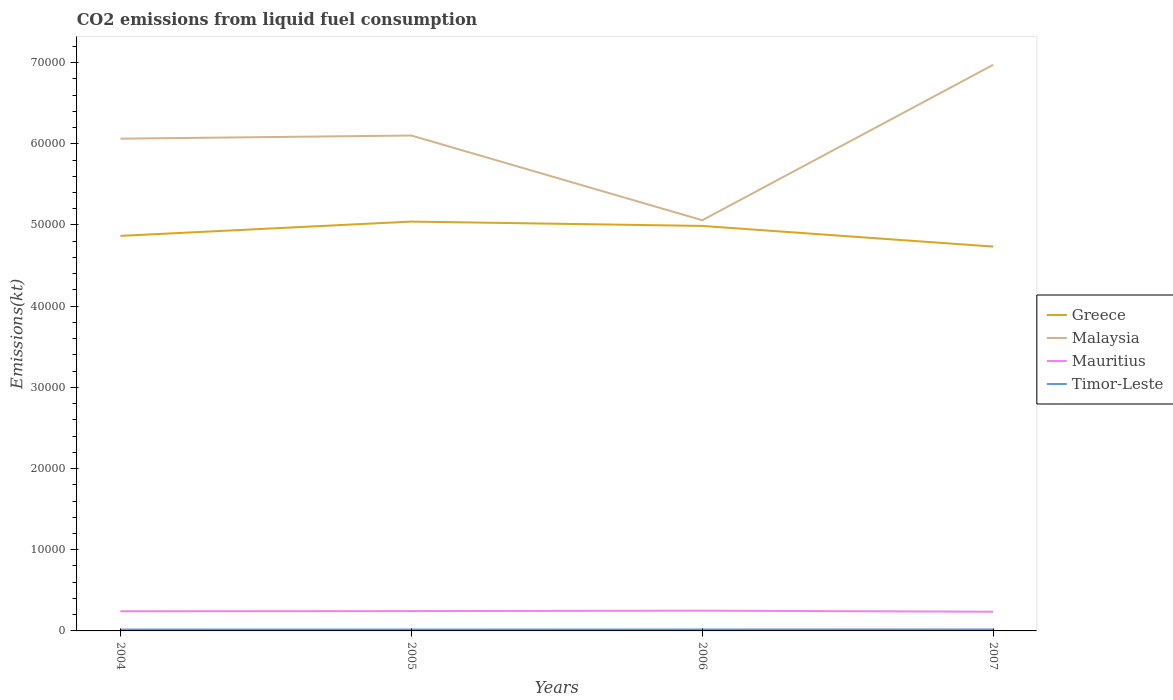How many different coloured lines are there?
Offer a terse response. 4. Does the line corresponding to Malaysia intersect with the line corresponding to Mauritius?
Provide a short and direct response. No. Is the number of lines equal to the number of legend labels?
Keep it short and to the point. Yes. Across all years, what is the maximum amount of CO2 emitted in Malaysia?
Your response must be concise. 5.06e+04. In which year was the amount of CO2 emitted in Mauritius maximum?
Offer a terse response. 2007. What is the total amount of CO2 emitted in Mauritius in the graph?
Make the answer very short. -18.34. What is the difference between the highest and the second highest amount of CO2 emitted in Mauritius?
Your answer should be compact. 128.34. Is the amount of CO2 emitted in Timor-Leste strictly greater than the amount of CO2 emitted in Greece over the years?
Make the answer very short. Yes. How many years are there in the graph?
Keep it short and to the point. 4. Does the graph contain any zero values?
Provide a succinct answer. No. How many legend labels are there?
Provide a succinct answer. 4. What is the title of the graph?
Offer a terse response. CO2 emissions from liquid fuel consumption. What is the label or title of the X-axis?
Make the answer very short. Years. What is the label or title of the Y-axis?
Ensure brevity in your answer.  Emissions(kt). What is the Emissions(kt) in Greece in 2004?
Keep it short and to the point. 4.87e+04. What is the Emissions(kt) in Malaysia in 2004?
Your answer should be compact. 6.06e+04. What is the Emissions(kt) of Mauritius in 2004?
Keep it short and to the point. 2423.89. What is the Emissions(kt) in Timor-Leste in 2004?
Make the answer very short. 176.02. What is the Emissions(kt) in Greece in 2005?
Your response must be concise. 5.04e+04. What is the Emissions(kt) of Malaysia in 2005?
Provide a succinct answer. 6.10e+04. What is the Emissions(kt) in Mauritius in 2005?
Your answer should be very brief. 2442.22. What is the Emissions(kt) in Timor-Leste in 2005?
Give a very brief answer. 176.02. What is the Emissions(kt) in Greece in 2006?
Offer a terse response. 4.99e+04. What is the Emissions(kt) of Malaysia in 2006?
Make the answer very short. 5.06e+04. What is the Emissions(kt) in Mauritius in 2006?
Make the answer very short. 2493.56. What is the Emissions(kt) of Timor-Leste in 2006?
Provide a succinct answer. 179.68. What is the Emissions(kt) of Greece in 2007?
Give a very brief answer. 4.73e+04. What is the Emissions(kt) in Malaysia in 2007?
Ensure brevity in your answer.  6.97e+04. What is the Emissions(kt) in Mauritius in 2007?
Your answer should be compact. 2365.22. What is the Emissions(kt) of Timor-Leste in 2007?
Give a very brief answer. 183.35. Across all years, what is the maximum Emissions(kt) in Greece?
Your response must be concise. 5.04e+04. Across all years, what is the maximum Emissions(kt) of Malaysia?
Ensure brevity in your answer.  6.97e+04. Across all years, what is the maximum Emissions(kt) of Mauritius?
Provide a succinct answer. 2493.56. Across all years, what is the maximum Emissions(kt) in Timor-Leste?
Offer a very short reply. 183.35. Across all years, what is the minimum Emissions(kt) in Greece?
Your answer should be compact. 4.73e+04. Across all years, what is the minimum Emissions(kt) of Malaysia?
Your answer should be very brief. 5.06e+04. Across all years, what is the minimum Emissions(kt) of Mauritius?
Give a very brief answer. 2365.22. Across all years, what is the minimum Emissions(kt) of Timor-Leste?
Give a very brief answer. 176.02. What is the total Emissions(kt) in Greece in the graph?
Provide a short and direct response. 1.96e+05. What is the total Emissions(kt) of Malaysia in the graph?
Provide a succinct answer. 2.42e+05. What is the total Emissions(kt) of Mauritius in the graph?
Your response must be concise. 9724.88. What is the total Emissions(kt) in Timor-Leste in the graph?
Offer a very short reply. 715.07. What is the difference between the Emissions(kt) in Greece in 2004 and that in 2005?
Offer a terse response. -1760.16. What is the difference between the Emissions(kt) of Malaysia in 2004 and that in 2005?
Make the answer very short. -388.7. What is the difference between the Emissions(kt) in Mauritius in 2004 and that in 2005?
Offer a terse response. -18.34. What is the difference between the Emissions(kt) of Timor-Leste in 2004 and that in 2005?
Your answer should be very brief. 0. What is the difference between the Emissions(kt) in Greece in 2004 and that in 2006?
Make the answer very short. -1224.78. What is the difference between the Emissions(kt) of Malaysia in 2004 and that in 2006?
Ensure brevity in your answer.  1.00e+04. What is the difference between the Emissions(kt) of Mauritius in 2004 and that in 2006?
Your answer should be very brief. -69.67. What is the difference between the Emissions(kt) of Timor-Leste in 2004 and that in 2006?
Your answer should be very brief. -3.67. What is the difference between the Emissions(kt) of Greece in 2004 and that in 2007?
Keep it short and to the point. 1320.12. What is the difference between the Emissions(kt) in Malaysia in 2004 and that in 2007?
Offer a very short reply. -9097.83. What is the difference between the Emissions(kt) of Mauritius in 2004 and that in 2007?
Give a very brief answer. 58.67. What is the difference between the Emissions(kt) of Timor-Leste in 2004 and that in 2007?
Provide a succinct answer. -7.33. What is the difference between the Emissions(kt) of Greece in 2005 and that in 2006?
Give a very brief answer. 535.38. What is the difference between the Emissions(kt) of Malaysia in 2005 and that in 2006?
Offer a terse response. 1.04e+04. What is the difference between the Emissions(kt) in Mauritius in 2005 and that in 2006?
Give a very brief answer. -51.34. What is the difference between the Emissions(kt) of Timor-Leste in 2005 and that in 2006?
Keep it short and to the point. -3.67. What is the difference between the Emissions(kt) in Greece in 2005 and that in 2007?
Make the answer very short. 3080.28. What is the difference between the Emissions(kt) in Malaysia in 2005 and that in 2007?
Your answer should be compact. -8709.12. What is the difference between the Emissions(kt) of Mauritius in 2005 and that in 2007?
Give a very brief answer. 77.01. What is the difference between the Emissions(kt) in Timor-Leste in 2005 and that in 2007?
Make the answer very short. -7.33. What is the difference between the Emissions(kt) of Greece in 2006 and that in 2007?
Your response must be concise. 2544.9. What is the difference between the Emissions(kt) in Malaysia in 2006 and that in 2007?
Make the answer very short. -1.91e+04. What is the difference between the Emissions(kt) of Mauritius in 2006 and that in 2007?
Your answer should be compact. 128.34. What is the difference between the Emissions(kt) of Timor-Leste in 2006 and that in 2007?
Keep it short and to the point. -3.67. What is the difference between the Emissions(kt) in Greece in 2004 and the Emissions(kt) in Malaysia in 2005?
Give a very brief answer. -1.24e+04. What is the difference between the Emissions(kt) of Greece in 2004 and the Emissions(kt) of Mauritius in 2005?
Offer a very short reply. 4.62e+04. What is the difference between the Emissions(kt) in Greece in 2004 and the Emissions(kt) in Timor-Leste in 2005?
Your answer should be compact. 4.85e+04. What is the difference between the Emissions(kt) of Malaysia in 2004 and the Emissions(kt) of Mauritius in 2005?
Offer a terse response. 5.82e+04. What is the difference between the Emissions(kt) of Malaysia in 2004 and the Emissions(kt) of Timor-Leste in 2005?
Your response must be concise. 6.05e+04. What is the difference between the Emissions(kt) of Mauritius in 2004 and the Emissions(kt) of Timor-Leste in 2005?
Give a very brief answer. 2247.87. What is the difference between the Emissions(kt) in Greece in 2004 and the Emissions(kt) in Malaysia in 2006?
Your answer should be compact. -1925.17. What is the difference between the Emissions(kt) in Greece in 2004 and the Emissions(kt) in Mauritius in 2006?
Offer a terse response. 4.62e+04. What is the difference between the Emissions(kt) of Greece in 2004 and the Emissions(kt) of Timor-Leste in 2006?
Your response must be concise. 4.85e+04. What is the difference between the Emissions(kt) in Malaysia in 2004 and the Emissions(kt) in Mauritius in 2006?
Your answer should be very brief. 5.81e+04. What is the difference between the Emissions(kt) in Malaysia in 2004 and the Emissions(kt) in Timor-Leste in 2006?
Ensure brevity in your answer.  6.05e+04. What is the difference between the Emissions(kt) in Mauritius in 2004 and the Emissions(kt) in Timor-Leste in 2006?
Offer a very short reply. 2244.2. What is the difference between the Emissions(kt) in Greece in 2004 and the Emissions(kt) in Malaysia in 2007?
Your answer should be compact. -2.11e+04. What is the difference between the Emissions(kt) in Greece in 2004 and the Emissions(kt) in Mauritius in 2007?
Ensure brevity in your answer.  4.63e+04. What is the difference between the Emissions(kt) in Greece in 2004 and the Emissions(kt) in Timor-Leste in 2007?
Make the answer very short. 4.85e+04. What is the difference between the Emissions(kt) of Malaysia in 2004 and the Emissions(kt) of Mauritius in 2007?
Make the answer very short. 5.83e+04. What is the difference between the Emissions(kt) of Malaysia in 2004 and the Emissions(kt) of Timor-Leste in 2007?
Make the answer very short. 6.05e+04. What is the difference between the Emissions(kt) in Mauritius in 2004 and the Emissions(kt) in Timor-Leste in 2007?
Keep it short and to the point. 2240.54. What is the difference between the Emissions(kt) of Greece in 2005 and the Emissions(kt) of Malaysia in 2006?
Offer a terse response. -165.01. What is the difference between the Emissions(kt) of Greece in 2005 and the Emissions(kt) of Mauritius in 2006?
Ensure brevity in your answer.  4.79e+04. What is the difference between the Emissions(kt) in Greece in 2005 and the Emissions(kt) in Timor-Leste in 2006?
Provide a short and direct response. 5.02e+04. What is the difference between the Emissions(kt) of Malaysia in 2005 and the Emissions(kt) of Mauritius in 2006?
Provide a succinct answer. 5.85e+04. What is the difference between the Emissions(kt) of Malaysia in 2005 and the Emissions(kt) of Timor-Leste in 2006?
Ensure brevity in your answer.  6.08e+04. What is the difference between the Emissions(kt) of Mauritius in 2005 and the Emissions(kt) of Timor-Leste in 2006?
Keep it short and to the point. 2262.54. What is the difference between the Emissions(kt) of Greece in 2005 and the Emissions(kt) of Malaysia in 2007?
Keep it short and to the point. -1.93e+04. What is the difference between the Emissions(kt) of Greece in 2005 and the Emissions(kt) of Mauritius in 2007?
Your answer should be very brief. 4.81e+04. What is the difference between the Emissions(kt) in Greece in 2005 and the Emissions(kt) in Timor-Leste in 2007?
Provide a succinct answer. 5.02e+04. What is the difference between the Emissions(kt) of Malaysia in 2005 and the Emissions(kt) of Mauritius in 2007?
Your answer should be very brief. 5.87e+04. What is the difference between the Emissions(kt) of Malaysia in 2005 and the Emissions(kt) of Timor-Leste in 2007?
Your answer should be compact. 6.08e+04. What is the difference between the Emissions(kt) of Mauritius in 2005 and the Emissions(kt) of Timor-Leste in 2007?
Offer a very short reply. 2258.87. What is the difference between the Emissions(kt) in Greece in 2006 and the Emissions(kt) in Malaysia in 2007?
Ensure brevity in your answer.  -1.98e+04. What is the difference between the Emissions(kt) in Greece in 2006 and the Emissions(kt) in Mauritius in 2007?
Provide a short and direct response. 4.75e+04. What is the difference between the Emissions(kt) of Greece in 2006 and the Emissions(kt) of Timor-Leste in 2007?
Your response must be concise. 4.97e+04. What is the difference between the Emissions(kt) in Malaysia in 2006 and the Emissions(kt) in Mauritius in 2007?
Offer a very short reply. 4.82e+04. What is the difference between the Emissions(kt) of Malaysia in 2006 and the Emissions(kt) of Timor-Leste in 2007?
Your response must be concise. 5.04e+04. What is the difference between the Emissions(kt) in Mauritius in 2006 and the Emissions(kt) in Timor-Leste in 2007?
Provide a succinct answer. 2310.21. What is the average Emissions(kt) of Greece per year?
Offer a very short reply. 4.91e+04. What is the average Emissions(kt) of Malaysia per year?
Keep it short and to the point. 6.05e+04. What is the average Emissions(kt) of Mauritius per year?
Provide a succinct answer. 2431.22. What is the average Emissions(kt) of Timor-Leste per year?
Make the answer very short. 178.77. In the year 2004, what is the difference between the Emissions(kt) of Greece and Emissions(kt) of Malaysia?
Keep it short and to the point. -1.20e+04. In the year 2004, what is the difference between the Emissions(kt) of Greece and Emissions(kt) of Mauritius?
Keep it short and to the point. 4.62e+04. In the year 2004, what is the difference between the Emissions(kt) in Greece and Emissions(kt) in Timor-Leste?
Your response must be concise. 4.85e+04. In the year 2004, what is the difference between the Emissions(kt) of Malaysia and Emissions(kt) of Mauritius?
Make the answer very short. 5.82e+04. In the year 2004, what is the difference between the Emissions(kt) in Malaysia and Emissions(kt) in Timor-Leste?
Give a very brief answer. 6.05e+04. In the year 2004, what is the difference between the Emissions(kt) in Mauritius and Emissions(kt) in Timor-Leste?
Your answer should be very brief. 2247.87. In the year 2005, what is the difference between the Emissions(kt) of Greece and Emissions(kt) of Malaysia?
Provide a succinct answer. -1.06e+04. In the year 2005, what is the difference between the Emissions(kt) of Greece and Emissions(kt) of Mauritius?
Provide a succinct answer. 4.80e+04. In the year 2005, what is the difference between the Emissions(kt) of Greece and Emissions(kt) of Timor-Leste?
Your answer should be very brief. 5.02e+04. In the year 2005, what is the difference between the Emissions(kt) in Malaysia and Emissions(kt) in Mauritius?
Keep it short and to the point. 5.86e+04. In the year 2005, what is the difference between the Emissions(kt) in Malaysia and Emissions(kt) in Timor-Leste?
Give a very brief answer. 6.08e+04. In the year 2005, what is the difference between the Emissions(kt) in Mauritius and Emissions(kt) in Timor-Leste?
Your answer should be compact. 2266.21. In the year 2006, what is the difference between the Emissions(kt) of Greece and Emissions(kt) of Malaysia?
Your answer should be compact. -700.4. In the year 2006, what is the difference between the Emissions(kt) in Greece and Emissions(kt) in Mauritius?
Ensure brevity in your answer.  4.74e+04. In the year 2006, what is the difference between the Emissions(kt) in Greece and Emissions(kt) in Timor-Leste?
Provide a succinct answer. 4.97e+04. In the year 2006, what is the difference between the Emissions(kt) in Malaysia and Emissions(kt) in Mauritius?
Give a very brief answer. 4.81e+04. In the year 2006, what is the difference between the Emissions(kt) of Malaysia and Emissions(kt) of Timor-Leste?
Make the answer very short. 5.04e+04. In the year 2006, what is the difference between the Emissions(kt) in Mauritius and Emissions(kt) in Timor-Leste?
Your answer should be very brief. 2313.88. In the year 2007, what is the difference between the Emissions(kt) of Greece and Emissions(kt) of Malaysia?
Your response must be concise. -2.24e+04. In the year 2007, what is the difference between the Emissions(kt) of Greece and Emissions(kt) of Mauritius?
Provide a short and direct response. 4.50e+04. In the year 2007, what is the difference between the Emissions(kt) in Greece and Emissions(kt) in Timor-Leste?
Your response must be concise. 4.72e+04. In the year 2007, what is the difference between the Emissions(kt) of Malaysia and Emissions(kt) of Mauritius?
Provide a succinct answer. 6.74e+04. In the year 2007, what is the difference between the Emissions(kt) in Malaysia and Emissions(kt) in Timor-Leste?
Your answer should be very brief. 6.95e+04. In the year 2007, what is the difference between the Emissions(kt) of Mauritius and Emissions(kt) of Timor-Leste?
Keep it short and to the point. 2181.86. What is the ratio of the Emissions(kt) of Greece in 2004 to that in 2005?
Your answer should be very brief. 0.97. What is the ratio of the Emissions(kt) of Malaysia in 2004 to that in 2005?
Offer a terse response. 0.99. What is the ratio of the Emissions(kt) in Mauritius in 2004 to that in 2005?
Your answer should be compact. 0.99. What is the ratio of the Emissions(kt) of Timor-Leste in 2004 to that in 2005?
Offer a very short reply. 1. What is the ratio of the Emissions(kt) of Greece in 2004 to that in 2006?
Your answer should be compact. 0.98. What is the ratio of the Emissions(kt) of Malaysia in 2004 to that in 2006?
Provide a succinct answer. 1.2. What is the ratio of the Emissions(kt) of Mauritius in 2004 to that in 2006?
Your answer should be compact. 0.97. What is the ratio of the Emissions(kt) in Timor-Leste in 2004 to that in 2006?
Your answer should be compact. 0.98. What is the ratio of the Emissions(kt) of Greece in 2004 to that in 2007?
Provide a short and direct response. 1.03. What is the ratio of the Emissions(kt) of Malaysia in 2004 to that in 2007?
Make the answer very short. 0.87. What is the ratio of the Emissions(kt) in Mauritius in 2004 to that in 2007?
Provide a short and direct response. 1.02. What is the ratio of the Emissions(kt) of Timor-Leste in 2004 to that in 2007?
Your response must be concise. 0.96. What is the ratio of the Emissions(kt) in Greece in 2005 to that in 2006?
Your answer should be compact. 1.01. What is the ratio of the Emissions(kt) of Malaysia in 2005 to that in 2006?
Provide a short and direct response. 1.21. What is the ratio of the Emissions(kt) in Mauritius in 2005 to that in 2006?
Your answer should be compact. 0.98. What is the ratio of the Emissions(kt) in Timor-Leste in 2005 to that in 2006?
Keep it short and to the point. 0.98. What is the ratio of the Emissions(kt) of Greece in 2005 to that in 2007?
Keep it short and to the point. 1.07. What is the ratio of the Emissions(kt) of Malaysia in 2005 to that in 2007?
Make the answer very short. 0.88. What is the ratio of the Emissions(kt) of Mauritius in 2005 to that in 2007?
Ensure brevity in your answer.  1.03. What is the ratio of the Emissions(kt) in Timor-Leste in 2005 to that in 2007?
Give a very brief answer. 0.96. What is the ratio of the Emissions(kt) in Greece in 2006 to that in 2007?
Offer a very short reply. 1.05. What is the ratio of the Emissions(kt) of Malaysia in 2006 to that in 2007?
Offer a very short reply. 0.73. What is the ratio of the Emissions(kt) of Mauritius in 2006 to that in 2007?
Your response must be concise. 1.05. What is the ratio of the Emissions(kt) in Timor-Leste in 2006 to that in 2007?
Your answer should be compact. 0.98. What is the difference between the highest and the second highest Emissions(kt) in Greece?
Offer a very short reply. 535.38. What is the difference between the highest and the second highest Emissions(kt) in Malaysia?
Provide a short and direct response. 8709.12. What is the difference between the highest and the second highest Emissions(kt) of Mauritius?
Your answer should be very brief. 51.34. What is the difference between the highest and the second highest Emissions(kt) of Timor-Leste?
Your response must be concise. 3.67. What is the difference between the highest and the lowest Emissions(kt) in Greece?
Keep it short and to the point. 3080.28. What is the difference between the highest and the lowest Emissions(kt) of Malaysia?
Provide a short and direct response. 1.91e+04. What is the difference between the highest and the lowest Emissions(kt) of Mauritius?
Keep it short and to the point. 128.34. What is the difference between the highest and the lowest Emissions(kt) of Timor-Leste?
Give a very brief answer. 7.33. 